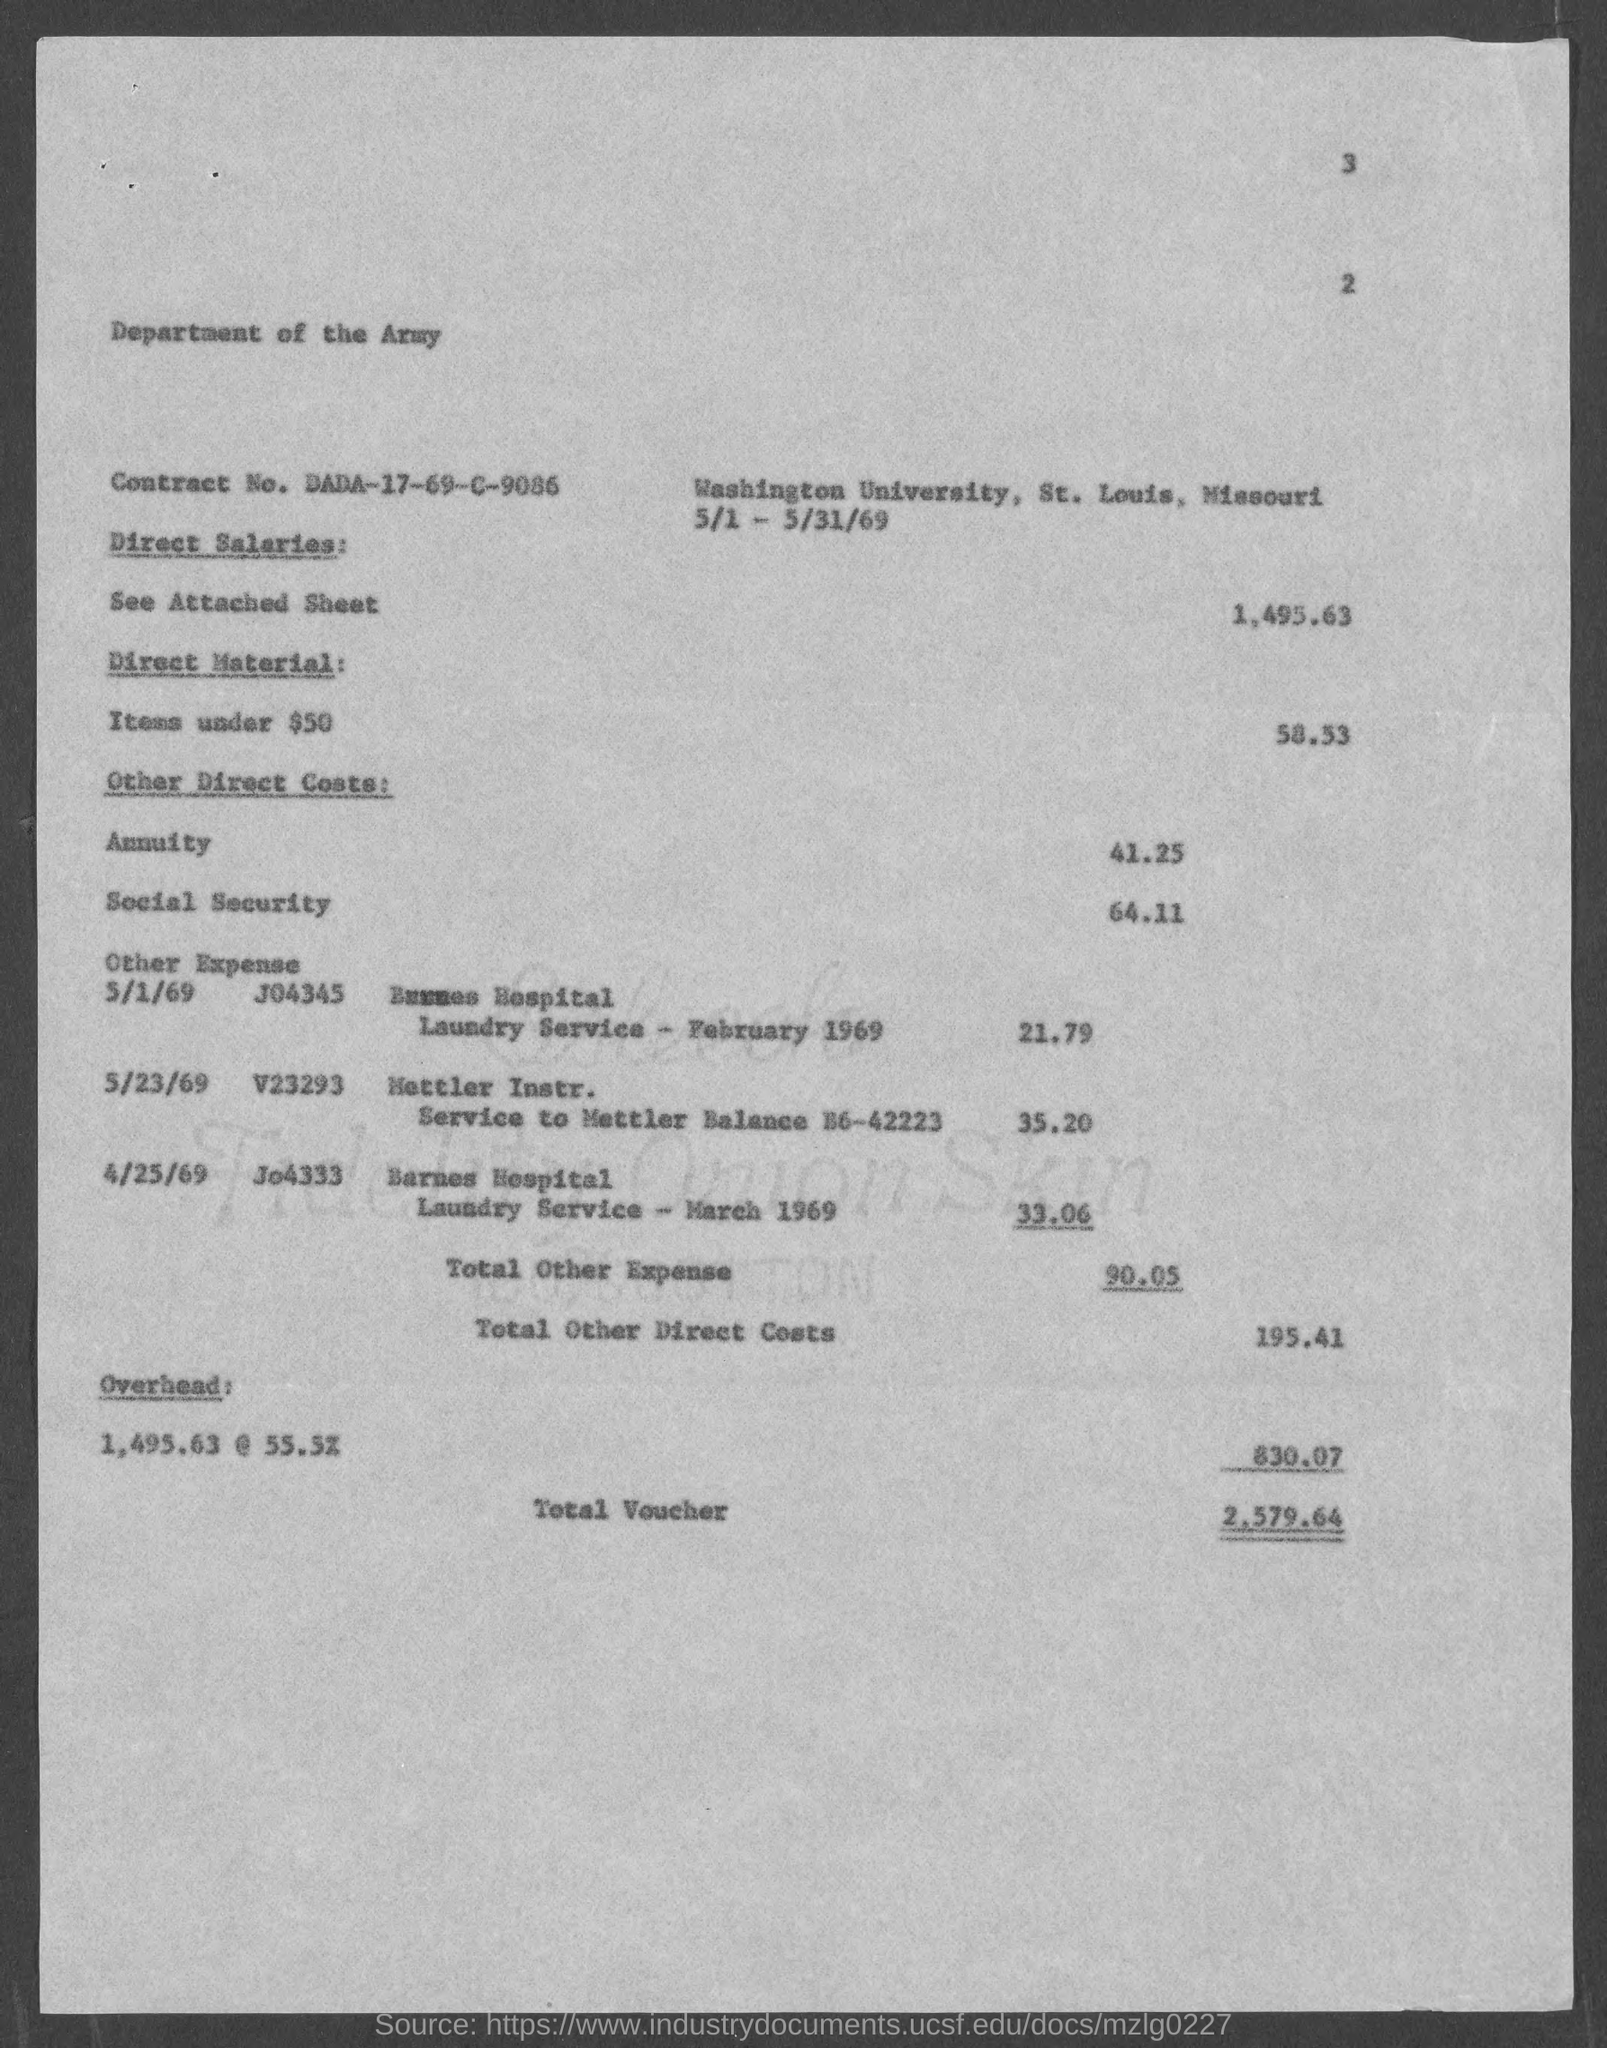List a handful of essential elements in this visual. The social security cost mentioned in the document is 64.11. The total voucher amount mentioned in the document is 2,579.64. The direct salaries cost mentioned in the document is 1,495.63. It is stated in the document that the overhead cost is 830.07. The Contract No. given in the document is DADA-17-69-C-9086.. 